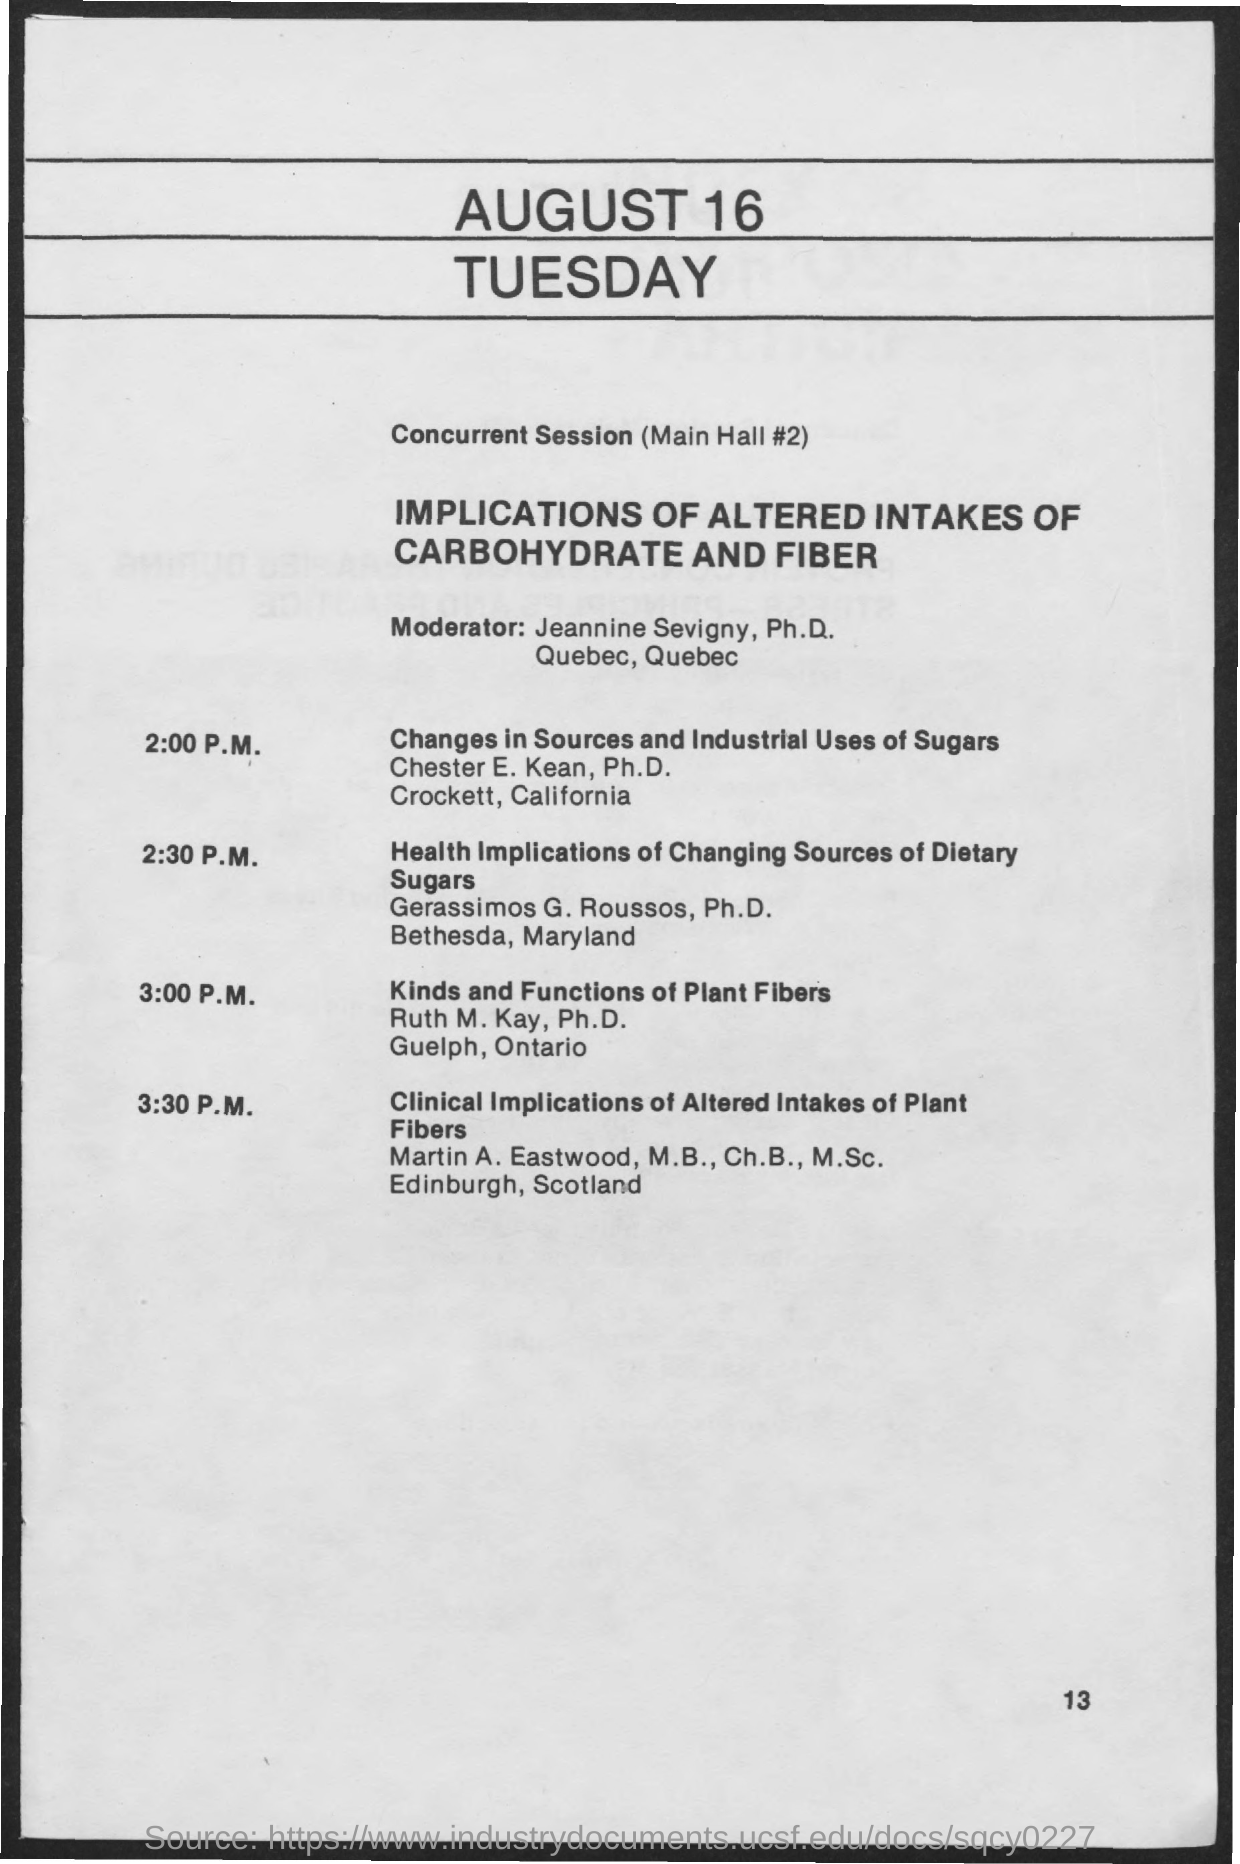Point out several critical features in this image. The date on the document is August 16. 